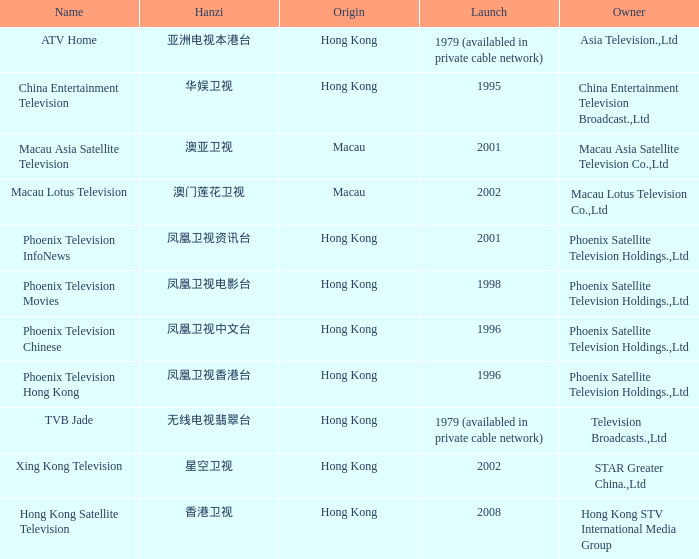What is the hanzi for phoenix television chinese, which was established in 1996? 凤凰卫视中文台. 